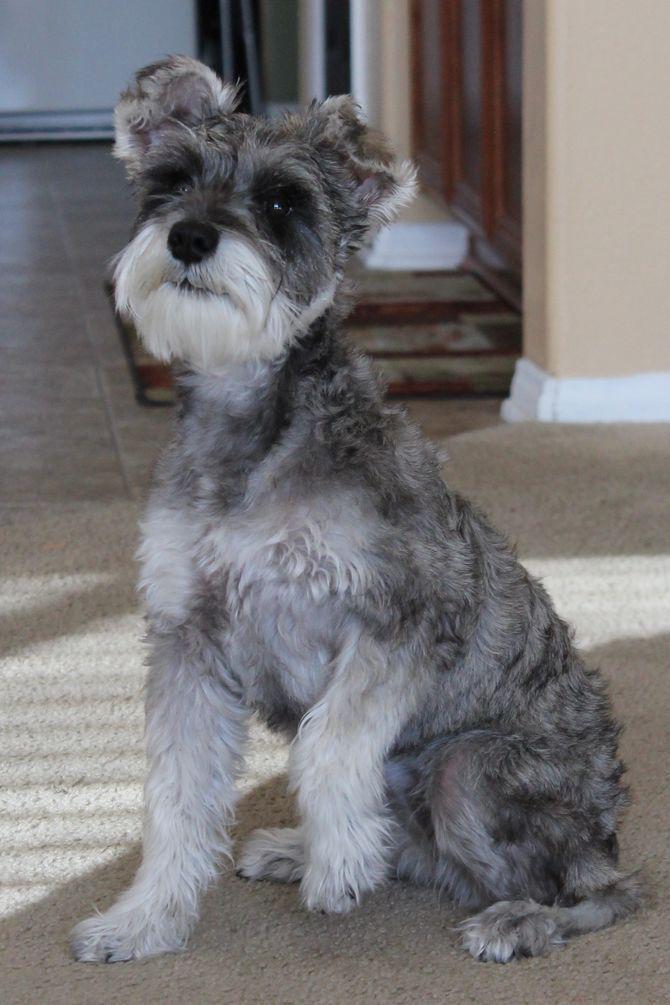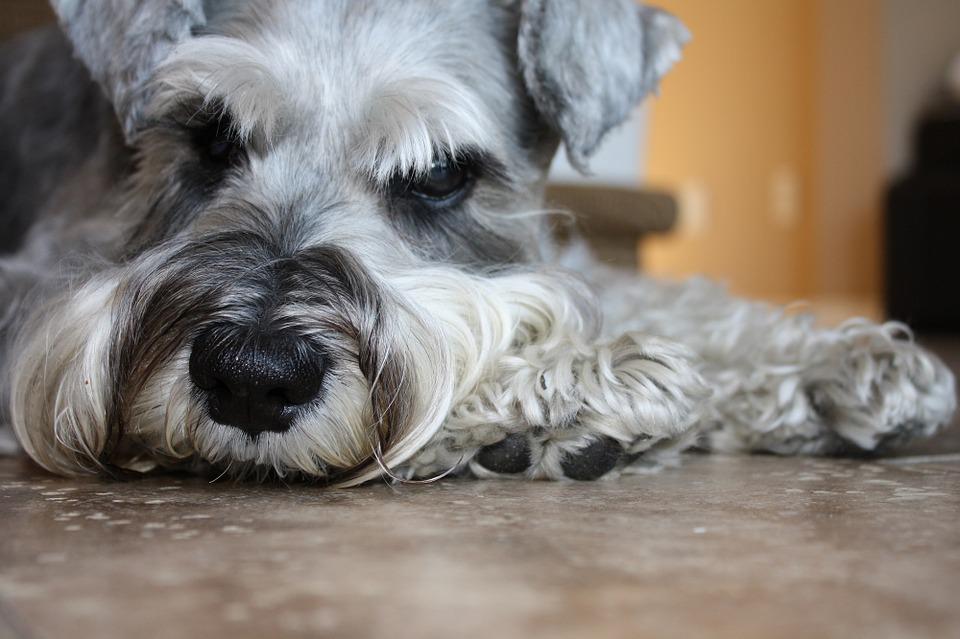The first image is the image on the left, the second image is the image on the right. Evaluate the accuracy of this statement regarding the images: "The dogs have collars on them.". Is it true? Answer yes or no. No. The first image is the image on the left, the second image is the image on the right. Evaluate the accuracy of this statement regarding the images: "In at least one image, there is a single dog with white paws and ears sitting facing left.". Is it true? Answer yes or no. No. 